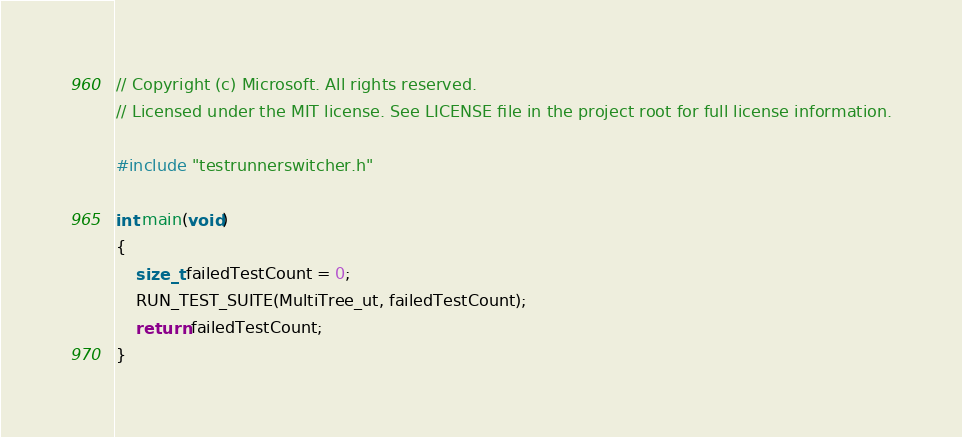Convert code to text. <code><loc_0><loc_0><loc_500><loc_500><_C_>// Copyright (c) Microsoft. All rights reserved.
// Licensed under the MIT license. See LICENSE file in the project root for full license information.

#include "testrunnerswitcher.h"

int main(void)
{
    size_t failedTestCount = 0;
    RUN_TEST_SUITE(MultiTree_ut, failedTestCount);
    return failedTestCount;
}
</code> 